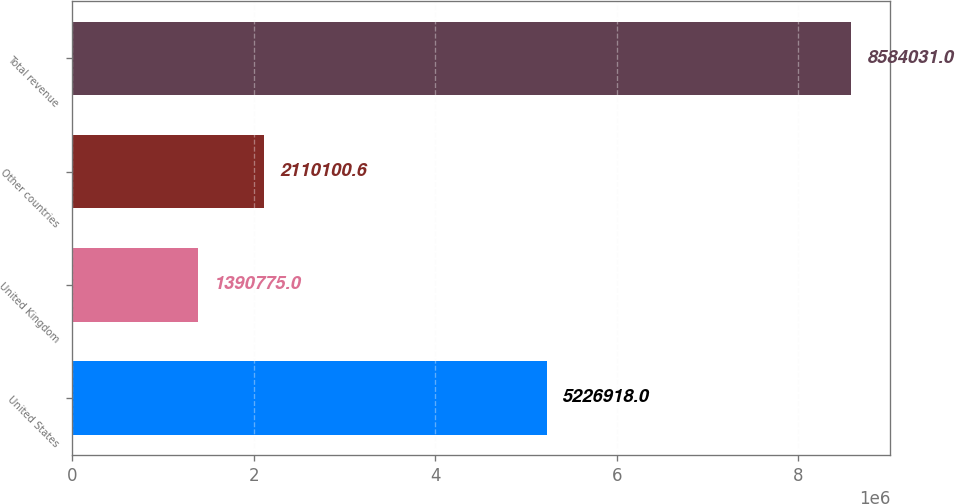Convert chart to OTSL. <chart><loc_0><loc_0><loc_500><loc_500><bar_chart><fcel>United States<fcel>United Kingdom<fcel>Other countries<fcel>Total revenue<nl><fcel>5.22692e+06<fcel>1.39078e+06<fcel>2.1101e+06<fcel>8.58403e+06<nl></chart> 